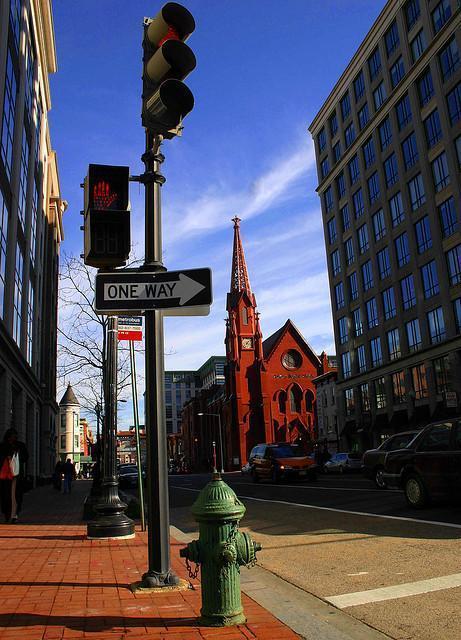How many traffic lights are in the photo?
Give a very brief answer. 2. How many cars are in the picture?
Give a very brief answer. 2. How many black motorcycles are there?
Give a very brief answer. 0. 